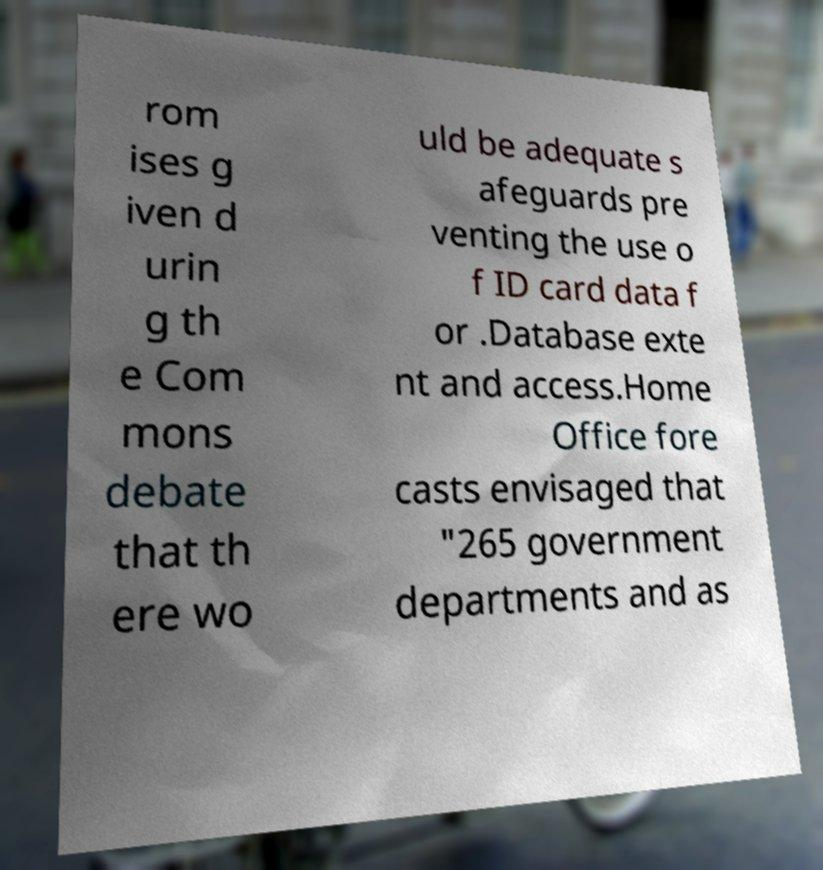Please read and relay the text visible in this image. What does it say? rom ises g iven d urin g th e Com mons debate that th ere wo uld be adequate s afeguards pre venting the use o f ID card data f or .Database exte nt and access.Home Office fore casts envisaged that "265 government departments and as 